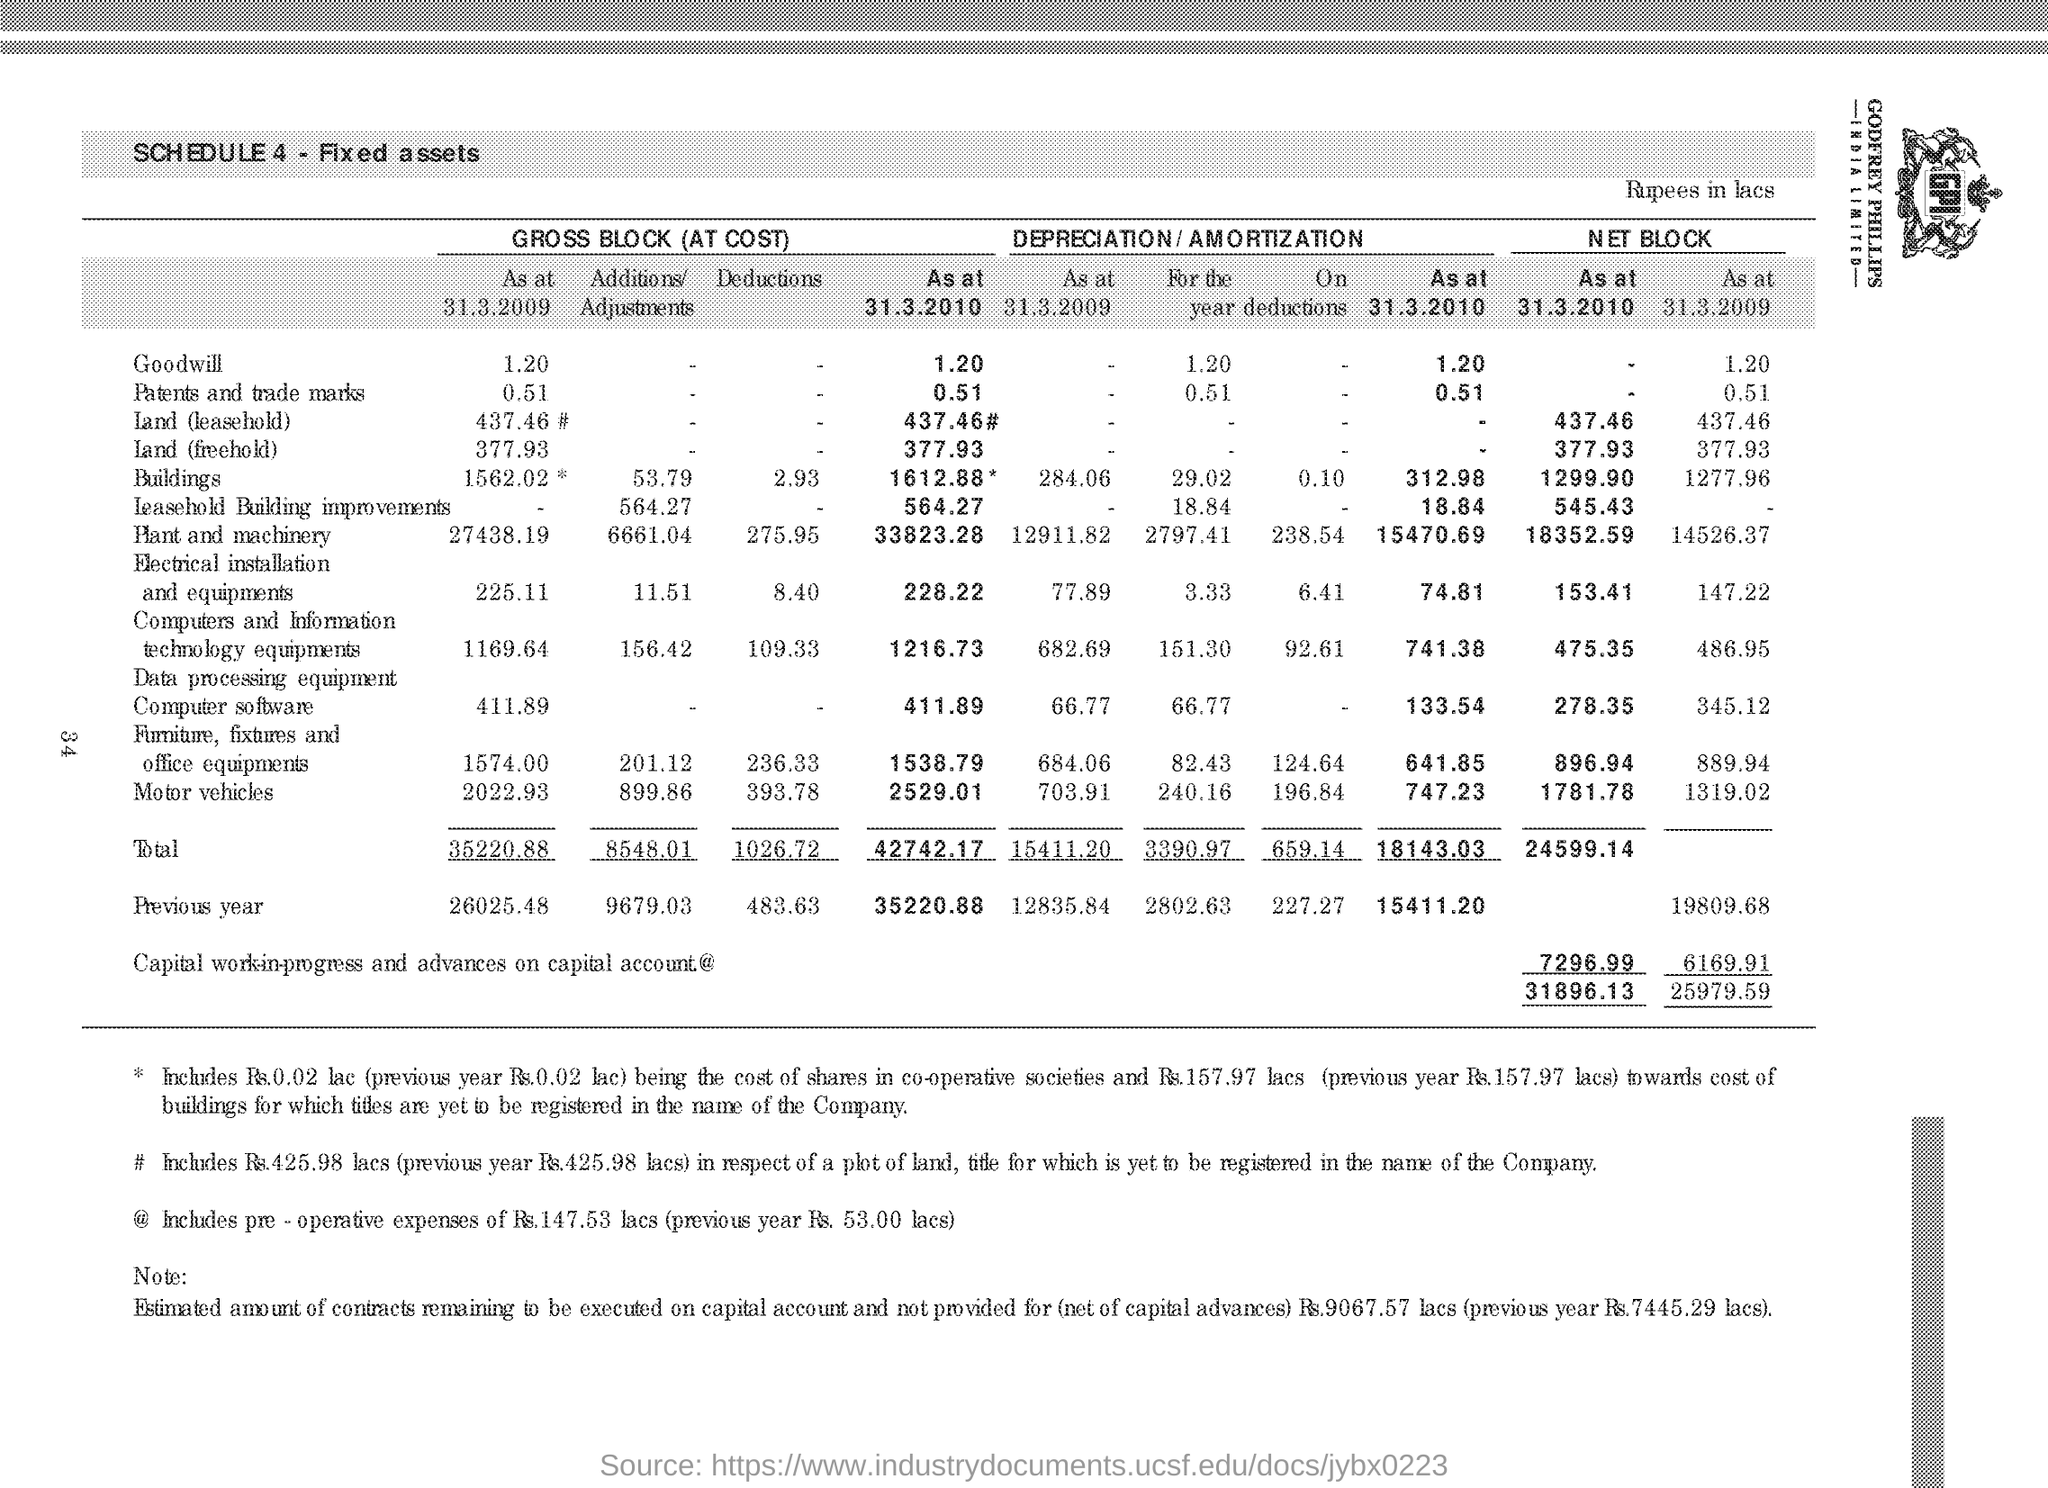Highlight a few significant elements in this photo. The net block of 'goodwill' at March 31, 2009 was 1.20. Land (leasehold) is the third fixed asset listed in the table from the top. The total cost of the "Gross Block" as of March 31, 2010 was 42,742.17. The previous year's gross block deductions were 483.63. The gross block deductions for motor vehicles is 393.78. 